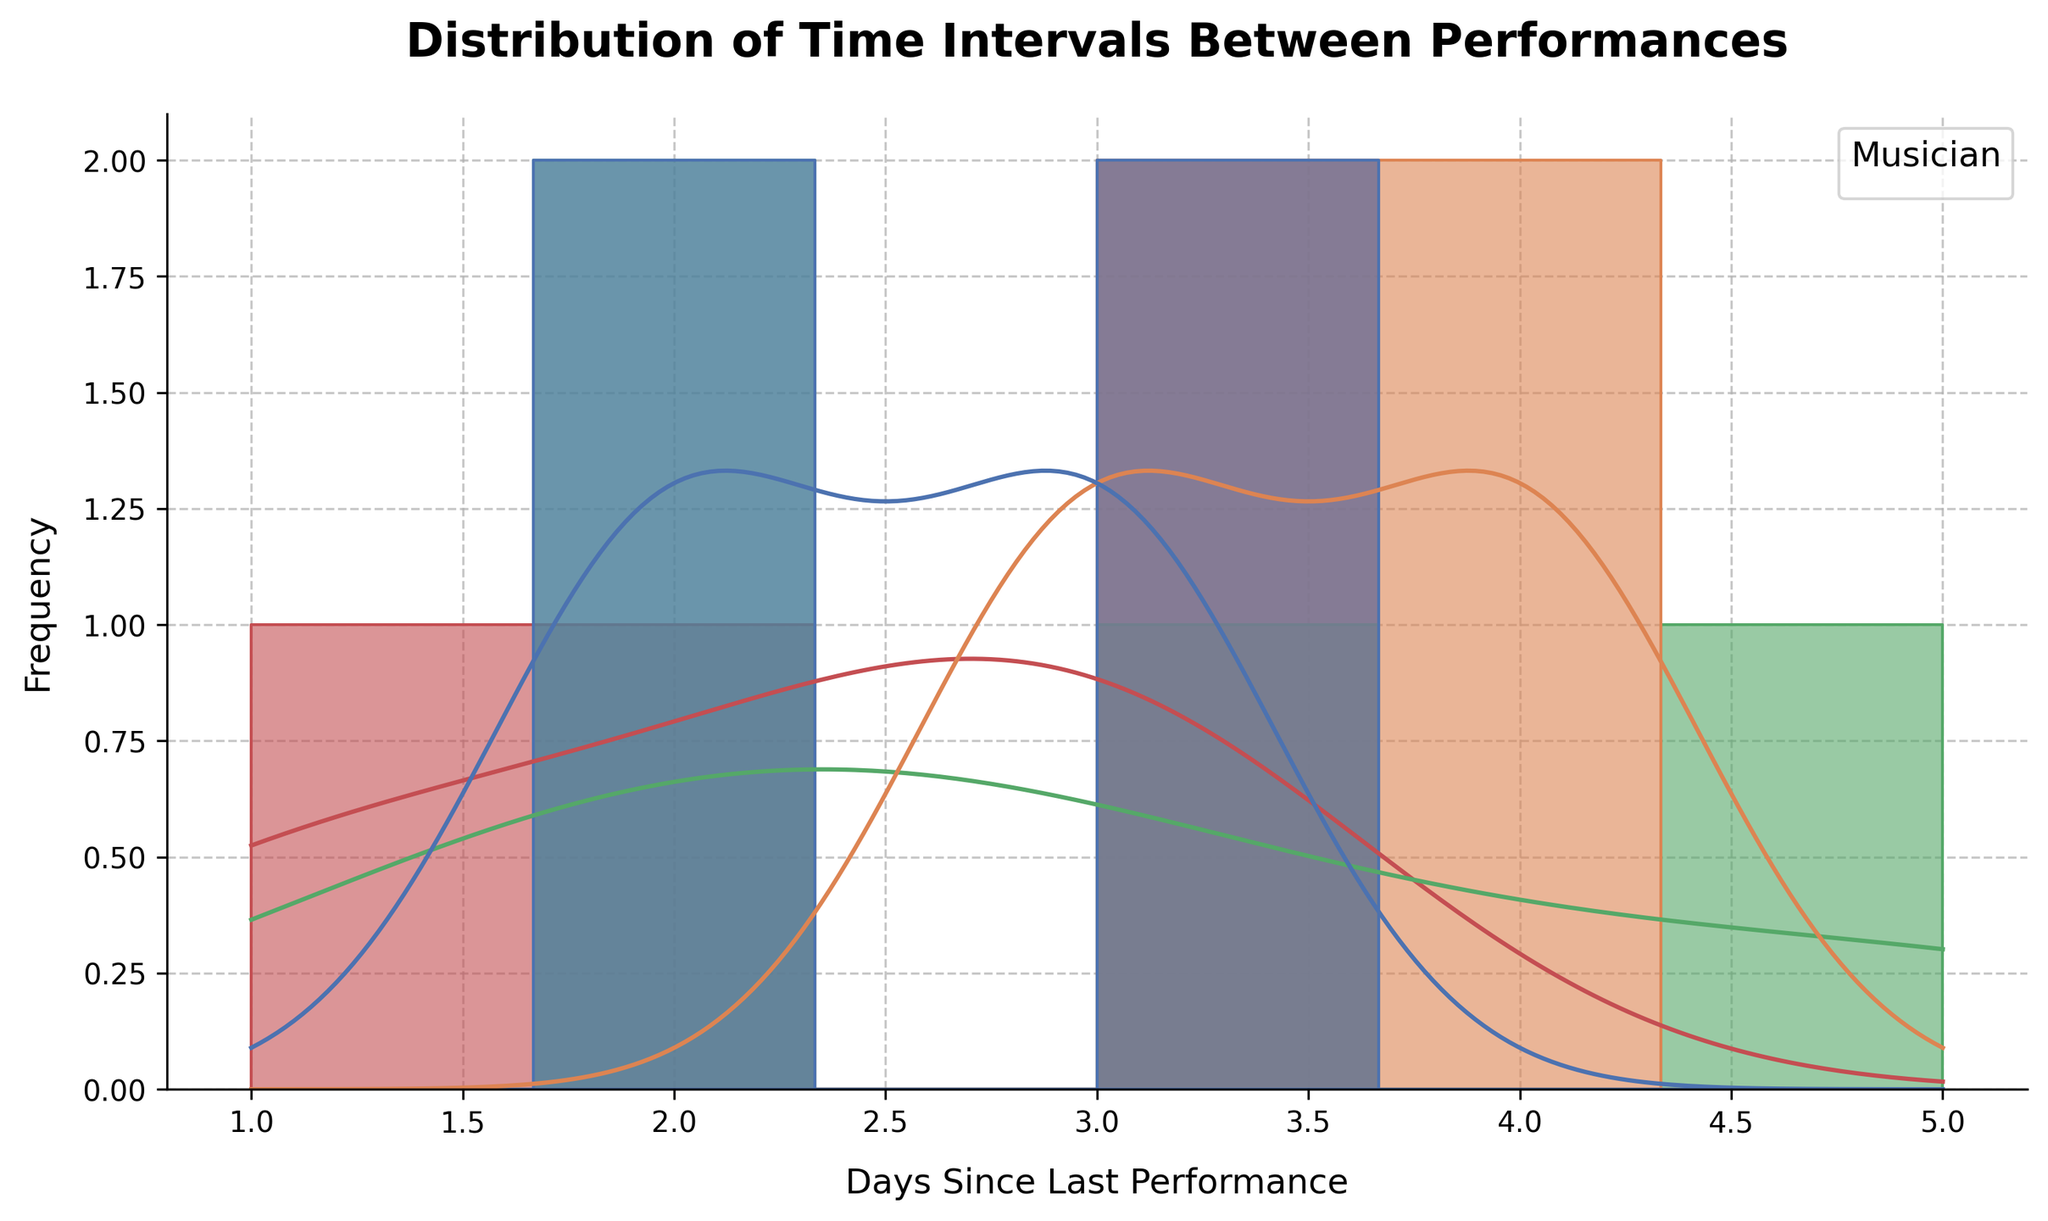What is the title of the figure? The title is usually located at the top of the plot and indicates what the plot is about. In this plot, it is "Distribution of Time Intervals Between Performances."
Answer: Distribution of Time Intervals Between Performances What does the x-axis represent? The x-axis label, positioned horizontally along the bottom of the plot, usually describes what the axis represents. Here, it is labeled "Days Since Last Performance."
Answer: Days Since Last Performance Which musician has the most frequent 3-day intervals between performances? By examining the plot, observe the peaks in frequency specifically for the 3-day intervals. The peak for Taylor Swift is the tallest for the 3-day interval.
Answer: Taylor Swift Which time interval appears most frequently in the overall data? Look at the tallest bars in the histogram regardless of the musician. The highest frequency can be spotted for the 3-day interval.
Answer: 3 days Does any musician have performances every 1 day? Focus on the histogram bar representing 1 day and identify any colored sections. There is only a small bar that appears, which belongs to Adele.
Answer: Adele Which musician has more varied time intervals between performances? Observe the spread of different colored bars along the x-axis. Taylor Swift's intervals show a wider range of different days compared to others.
Answer: Taylor Swift Who has the least frequent performances? Check for the musician with more gaps and lower frequency peaks. Ed Sheeran’s histogram bars are less frequent and spread out compared to others.
Answer: Ed Sheeran What is the average time interval for John Mayer's performances? Sum up the days between performances for John Mayer (2 + 3 + 2 + 3 = 10) and divide by the number of intervals (4). The average is 10/4 = 2.5 days.
Answer: 2.5 days 